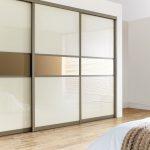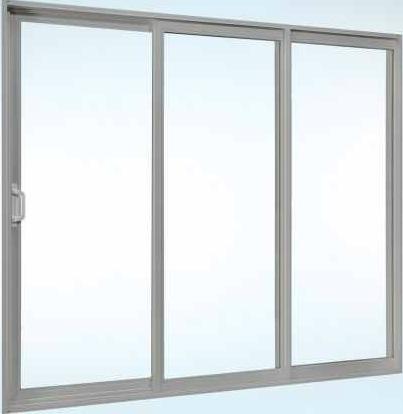The first image is the image on the left, the second image is the image on the right. Evaluate the accuracy of this statement regarding the images: "The door in one of the images is ajar.". Is it true? Answer yes or no. No. The first image is the image on the left, the second image is the image on the right. For the images shown, is this caption "An image shows a silver-framed sliding door unit with three plain glass panels." true? Answer yes or no. Yes. 